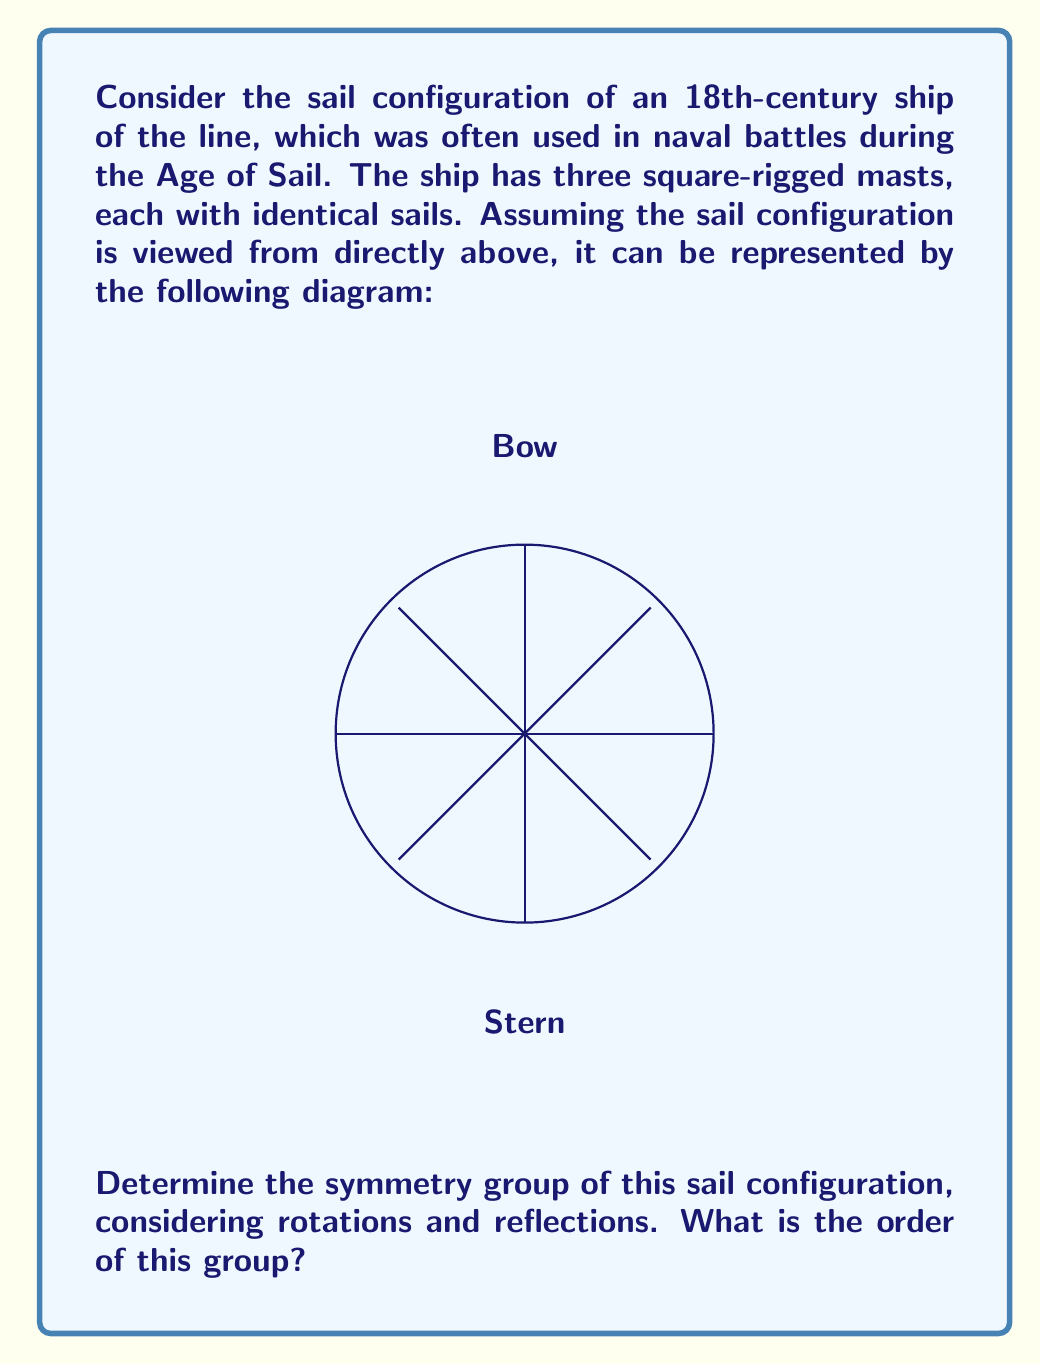Solve this math problem. To determine the symmetry group of the sail configuration, we need to identify all the symmetries that preserve the shape:

1. Rotations:
   - Identity (0° rotation)
   - 90° rotation clockwise and counterclockwise
   - 180° rotation

2. Reflections:
   - Reflection across the vertical axis (bow to stern)
   - Reflection across the horizontal axis (port to starboard)
   - Reflection across the diagonal from top-left to bottom-right
   - Reflection across the diagonal from top-right to bottom-left

These symmetries form a group under composition. Let's identify this group:

- It has 8 elements in total (4 rotations and 4 reflections).
- The rotations form a cyclic subgroup of order 4.
- The reflections, when composed with rotations, generate all 8 elements.

This group is isomorphic to the dihedral group $D_4$, which is the symmetry group of a square.

The order of the group is the number of elements, which is 8.

To verify this, we can check that:
- The group is closed under composition.
- The identity element exists (0° rotation).
- Each element has an inverse.
- The operation is associative.

All these properties hold for the symmetries we identified, confirming that it forms a group isomorphic to $D_4$.
Answer: $D_4$, order 8 